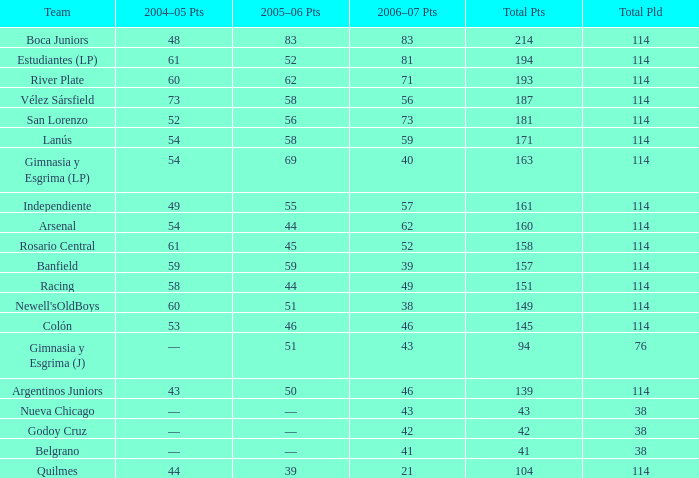What is the total pld with 158 points in 2006-07, and less than 52 points in 2006-07? None. 